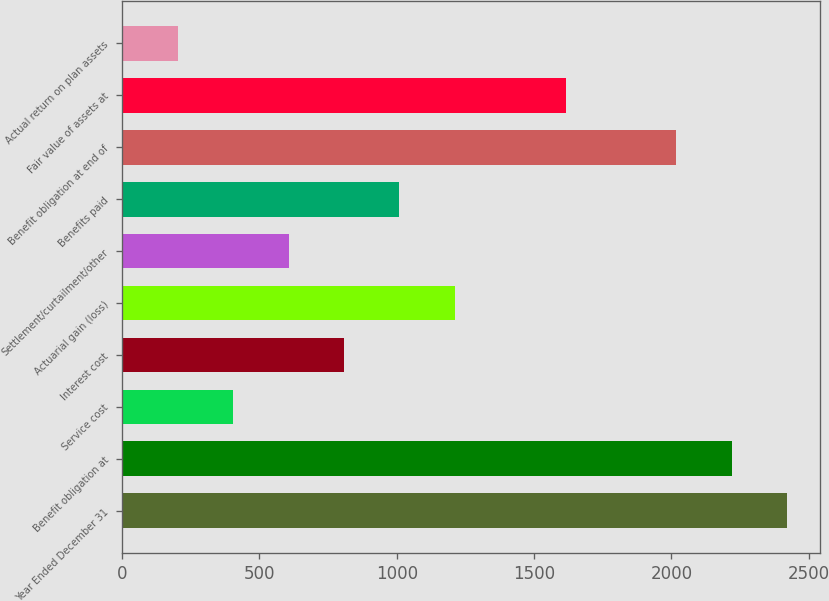Convert chart to OTSL. <chart><loc_0><loc_0><loc_500><loc_500><bar_chart><fcel>Year Ended December 31<fcel>Benefit obligation at<fcel>Service cost<fcel>Interest cost<fcel>Actuarial gain (loss)<fcel>Settlement/curtailment/other<fcel>Benefits paid<fcel>Benefit obligation at end of<fcel>Fair value of assets at<fcel>Actual return on plan assets<nl><fcel>2421.4<fcel>2219.7<fcel>404.4<fcel>807.8<fcel>1211.2<fcel>606.1<fcel>1009.5<fcel>2018<fcel>1614.6<fcel>202.7<nl></chart> 